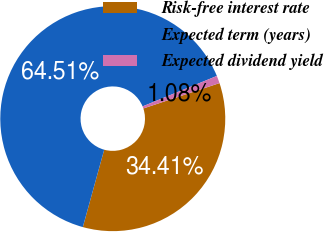<chart> <loc_0><loc_0><loc_500><loc_500><pie_chart><fcel>Risk-free interest rate<fcel>Expected term (years)<fcel>Expected dividend yield<nl><fcel>34.41%<fcel>64.52%<fcel>1.08%<nl></chart> 